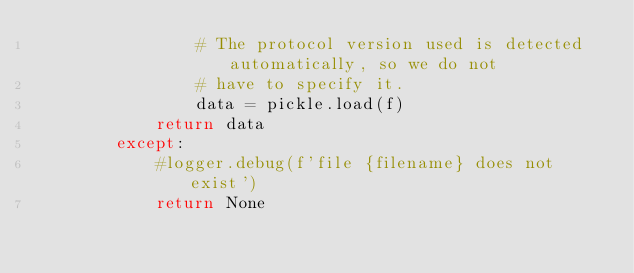<code> <loc_0><loc_0><loc_500><loc_500><_Python_>                # The protocol version used is detected automatically, so we do not
                # have to specify it.
                data = pickle.load(f)
            return data
        except:
            #logger.debug(f'file {filename} does not exist')
            return None
</code> 